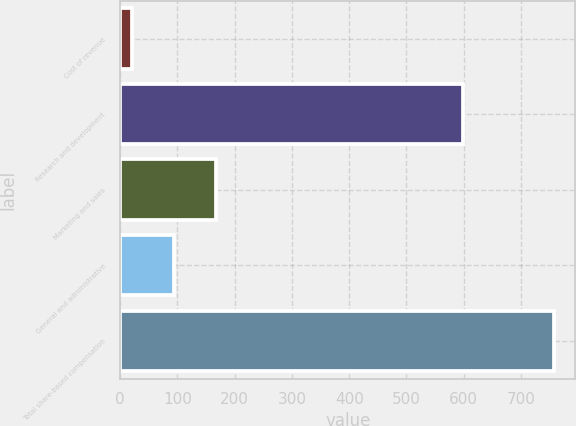<chart> <loc_0><loc_0><loc_500><loc_500><bar_chart><fcel>Cost of revenue<fcel>Research and development<fcel>Marketing and sales<fcel>General and administrative<fcel>Total share-based compensation<nl><fcel>21<fcel>598<fcel>168.2<fcel>94.6<fcel>757<nl></chart> 